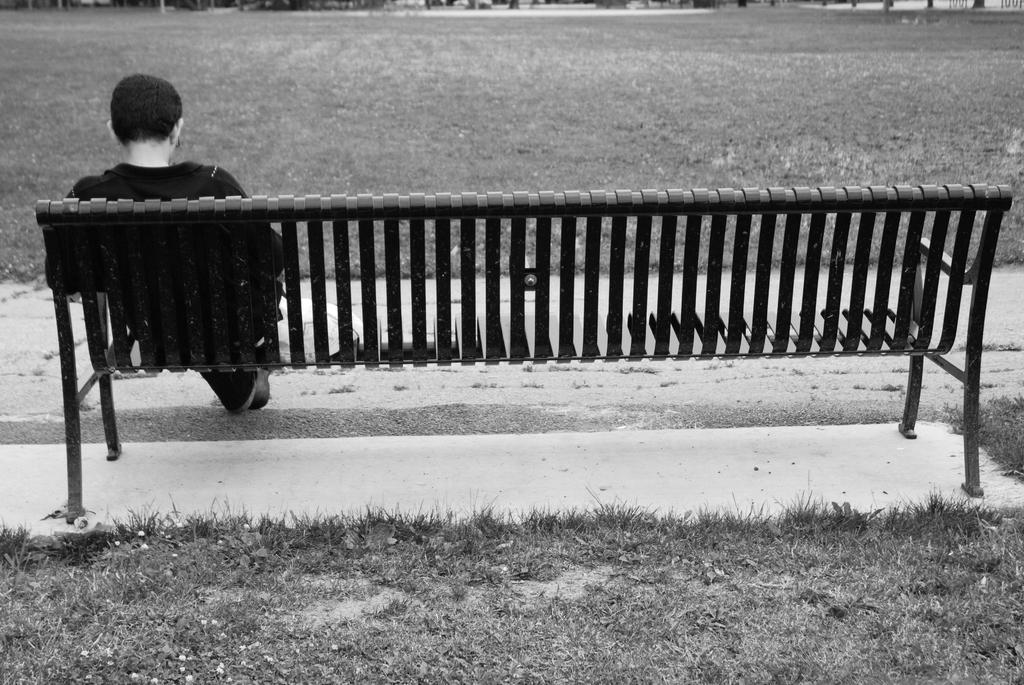What is the color scheme of the image? The image is black and white. What is the man in the image doing? The man is sitting on a bench in the image. What type of environment is visible in the image? There is a grass field in front of the man. What type of pancake is the man eating in the image? There is no pancake present in the image; the man is sitting on a bench in a black and white image with a grass field in front of him. 